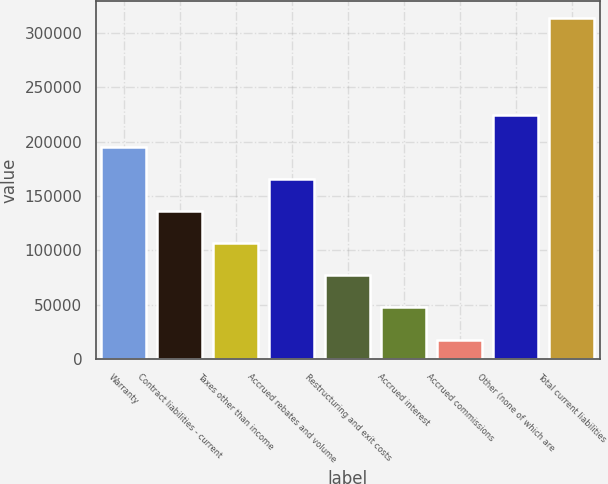Convert chart. <chart><loc_0><loc_0><loc_500><loc_500><bar_chart><fcel>Warranty<fcel>Contract liabilities - current<fcel>Taxes other than income<fcel>Accrued rebates and volume<fcel>Restructuring and exit costs<fcel>Accrued interest<fcel>Accrued commissions<fcel>Other (none of which are<fcel>Total current liabilities<nl><fcel>195210<fcel>136089<fcel>106528<fcel>165650<fcel>76968<fcel>47407.5<fcel>17847<fcel>224770<fcel>313452<nl></chart> 